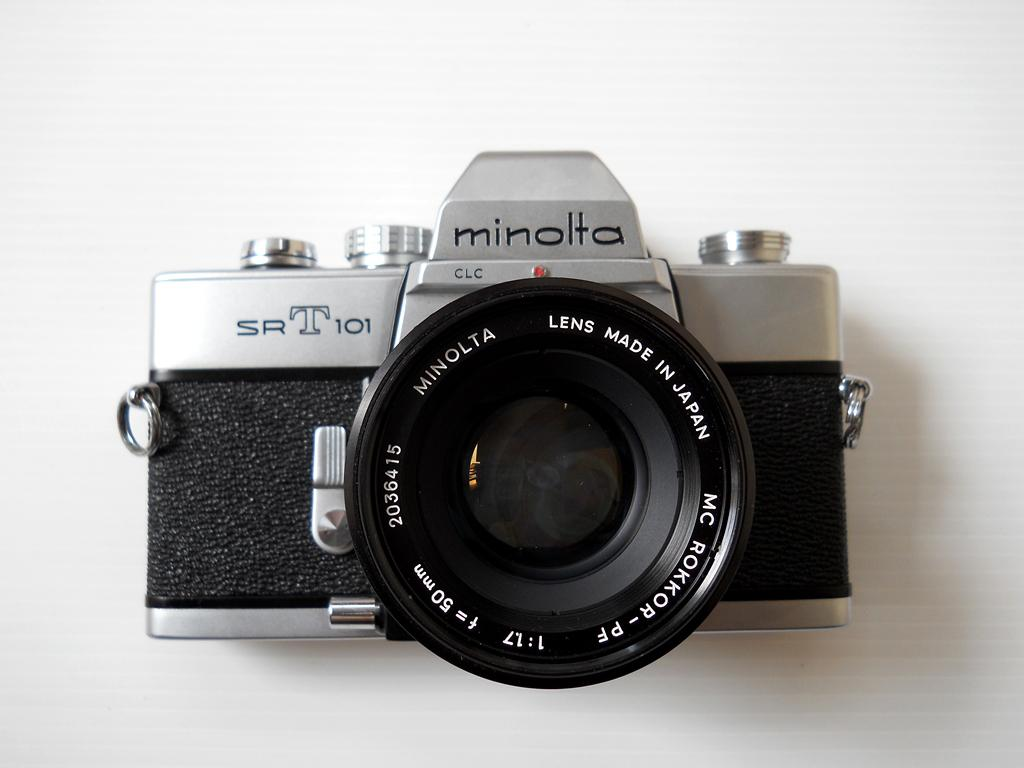Provide a one-sentence caption for the provided image. An old fashioned camera with the logo minolta on the top. 